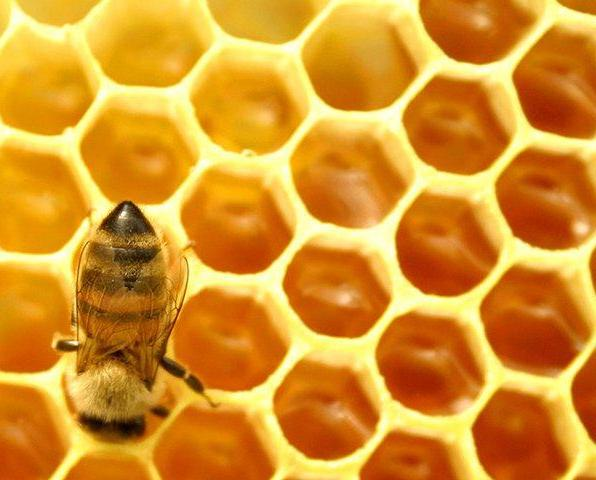What role does the texture of the bee's body play in its daily activities? The soft, fuzzy texture of the bee's body, particularly noticeable on its thorax, is crucial for pollen collection. As bees visit flowers, pollen grains stick to these hairy parts, allowing bees to transport pollen efficiently from one flower to another, facilitating pollination, which is essential for agricultural productivity and ecosystem health. 